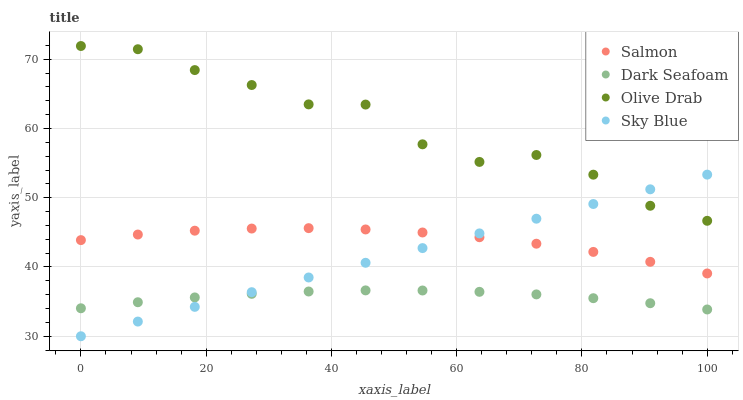Does Dark Seafoam have the minimum area under the curve?
Answer yes or no. Yes. Does Olive Drab have the maximum area under the curve?
Answer yes or no. Yes. Does Salmon have the minimum area under the curve?
Answer yes or no. No. Does Salmon have the maximum area under the curve?
Answer yes or no. No. Is Sky Blue the smoothest?
Answer yes or no. Yes. Is Olive Drab the roughest?
Answer yes or no. Yes. Is Dark Seafoam the smoothest?
Answer yes or no. No. Is Dark Seafoam the roughest?
Answer yes or no. No. Does Sky Blue have the lowest value?
Answer yes or no. Yes. Does Dark Seafoam have the lowest value?
Answer yes or no. No. Does Olive Drab have the highest value?
Answer yes or no. Yes. Does Salmon have the highest value?
Answer yes or no. No. Is Dark Seafoam less than Olive Drab?
Answer yes or no. Yes. Is Salmon greater than Dark Seafoam?
Answer yes or no. Yes. Does Sky Blue intersect Olive Drab?
Answer yes or no. Yes. Is Sky Blue less than Olive Drab?
Answer yes or no. No. Is Sky Blue greater than Olive Drab?
Answer yes or no. No. Does Dark Seafoam intersect Olive Drab?
Answer yes or no. No. 